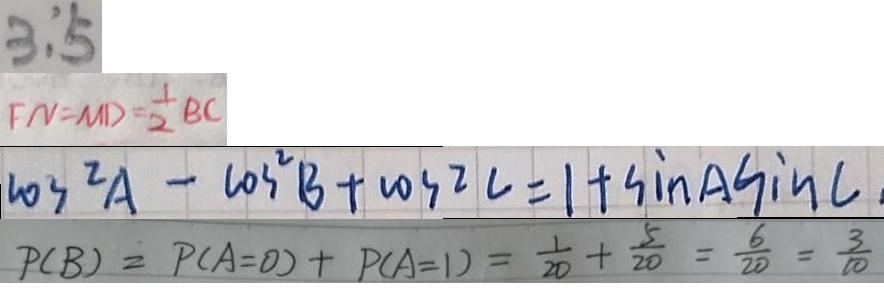Convert formula to latex. <formula><loc_0><loc_0><loc_500><loc_500>3 : 5 
 F N = M D = \frac { 1 } { 2 } B C 
 \cos ^ { 2 } A - \cos ^ { 2 } B + \cos 2 C = 1 + \sin C 
 P ( B ) = P ( A = 0 ) + P ( A = 1 ) = \frac { 1 } { 2 0 } + \frac { 5 } { 2 0 } = \frac { 6 } { 2 0 } = \frac { 3 } { 1 0 }</formula> 